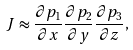Convert formula to latex. <formula><loc_0><loc_0><loc_500><loc_500>J \approx \frac { \partial p _ { 1 } } { \partial x } \frac { \partial p _ { 2 } } { \partial y } \frac { \partial p _ { 3 } } { \partial z } ,</formula> 